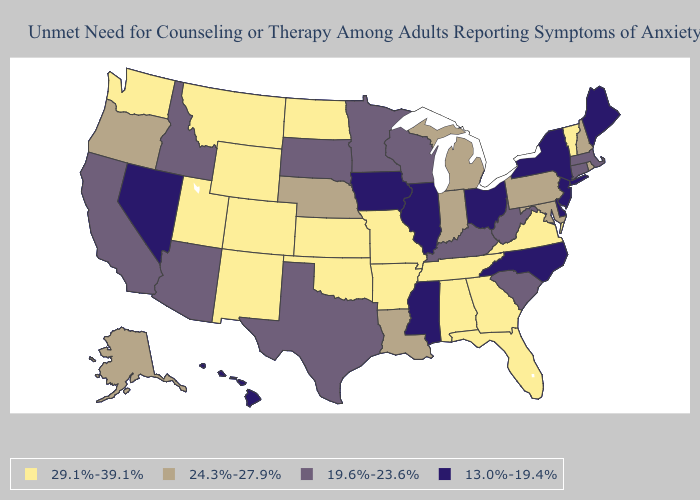Name the states that have a value in the range 24.3%-27.9%?
Answer briefly. Alaska, Indiana, Louisiana, Maryland, Michigan, Nebraska, New Hampshire, Oregon, Pennsylvania, Rhode Island. Does Oregon have the lowest value in the USA?
Answer briefly. No. What is the value of North Carolina?
Answer briefly. 13.0%-19.4%. Among the states that border Tennessee , which have the lowest value?
Quick response, please. Mississippi, North Carolina. Does Minnesota have the lowest value in the MidWest?
Write a very short answer. No. Name the states that have a value in the range 24.3%-27.9%?
Quick response, please. Alaska, Indiana, Louisiana, Maryland, Michigan, Nebraska, New Hampshire, Oregon, Pennsylvania, Rhode Island. Which states have the lowest value in the MidWest?
Write a very short answer. Illinois, Iowa, Ohio. Does Delaware have the same value as Idaho?
Give a very brief answer. No. What is the value of Delaware?
Concise answer only. 13.0%-19.4%. Among the states that border Missouri , does Iowa have the highest value?
Answer briefly. No. Name the states that have a value in the range 13.0%-19.4%?
Write a very short answer. Delaware, Hawaii, Illinois, Iowa, Maine, Mississippi, Nevada, New Jersey, New York, North Carolina, Ohio. Is the legend a continuous bar?
Keep it brief. No. Is the legend a continuous bar?
Quick response, please. No. What is the value of Colorado?
Be succinct. 29.1%-39.1%. Does North Dakota have the same value as Kansas?
Concise answer only. Yes. 